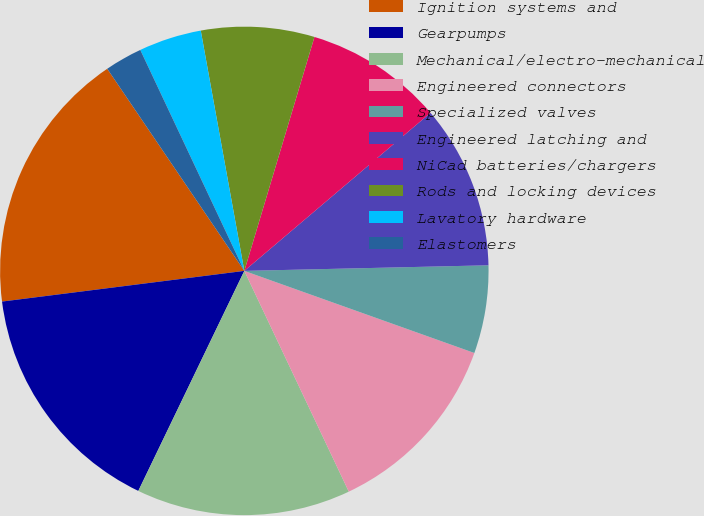Convert chart. <chart><loc_0><loc_0><loc_500><loc_500><pie_chart><fcel>Ignition systems and<fcel>Gearpumps<fcel>Mechanical/electro-mechanical<fcel>Engineered connectors<fcel>Specialized valves<fcel>Engineered latching and<fcel>NiCad batteries/chargers<fcel>Rods and locking devices<fcel>Lavatory hardware<fcel>Elastomers<nl><fcel>17.52%<fcel>15.85%<fcel>14.18%<fcel>12.51%<fcel>5.82%<fcel>10.84%<fcel>9.16%<fcel>7.49%<fcel>4.15%<fcel>2.48%<nl></chart> 